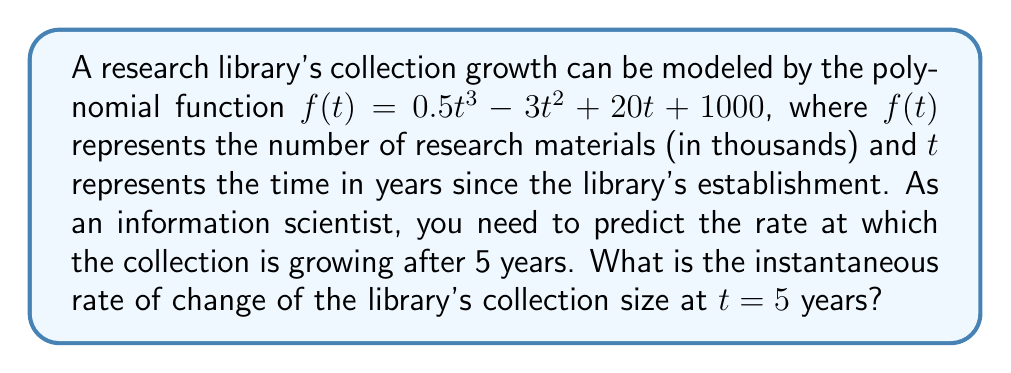Can you answer this question? To find the instantaneous rate of change at $t = 5$, we need to follow these steps:

1) The instantaneous rate of change is given by the derivative of the function at the specified point.

2) First, let's find the derivative of $f(t)$:
   $$f'(t) = \frac{d}{dt}(0.5t^3 - 3t^2 + 20t + 1000)$$
   $$f'(t) = 1.5t^2 - 6t + 20$$

3) Now, we need to evaluate $f'(t)$ at $t = 5$:
   $$f'(5) = 1.5(5^2) - 6(5) + 20$$
   $$f'(5) = 1.5(25) - 30 + 20$$
   $$f'(5) = 37.5 - 30 + 20$$
   $$f'(5) = 27.5$$

4) The result 27.5 represents the rate of change in thousands of research materials per year.

5) To convert this to the actual number of research materials, we multiply by 1000:
   $$27.5 * 1000 = 27,500$$

Therefore, after 5 years, the library's collection is growing at a rate of 27,500 research materials per year.
Answer: 27,500 research materials per year 